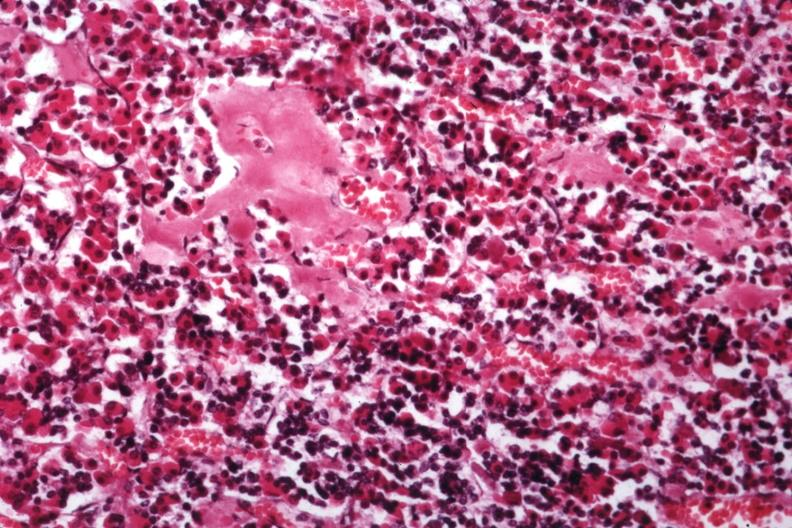what had incontinence headaches and failure to maintain weight very strange case not amyloid angiopathy r. endocrine is present?
Answer the question using a single word or phrase. Hyalin mass in pituitary which there are several slides from this in this file 23 yowf limited brain 